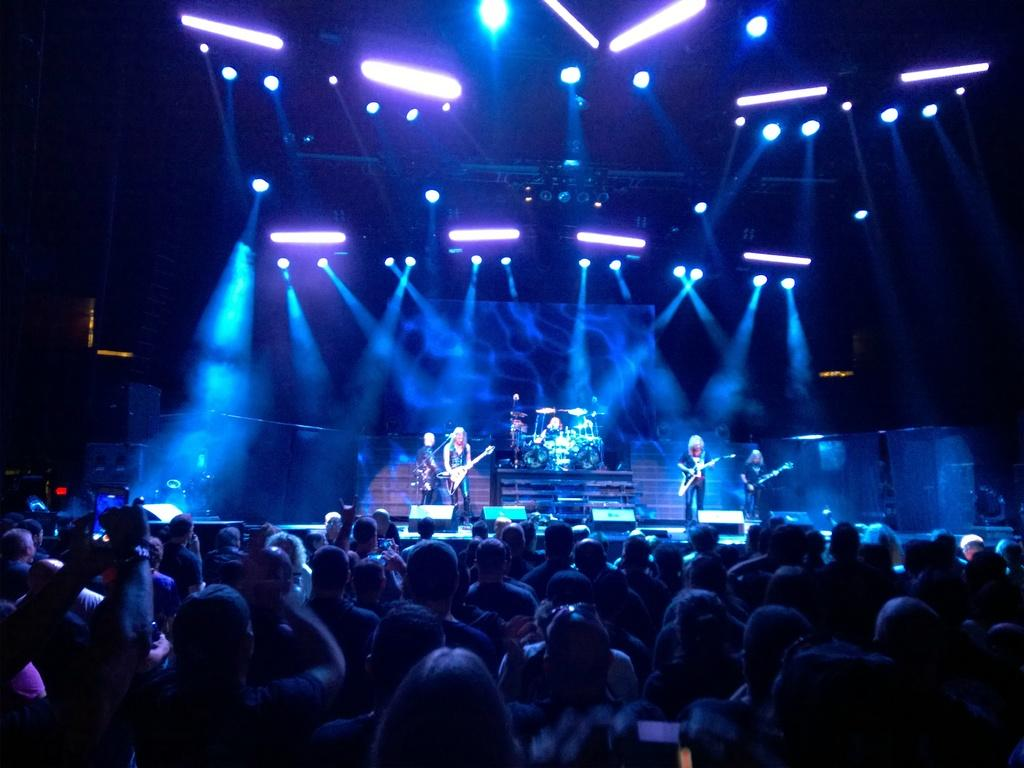What is happening in the image involving the group of people? Some people are standing and holding musical instruments. What objects are present in the image that might be related to the musical performance? There are lights visible in the image and a speaker. How many ladybugs can be seen crawling on the speaker in the image? There are no ladybugs present in the image; the speaker is not mentioned as having any insects on it. 